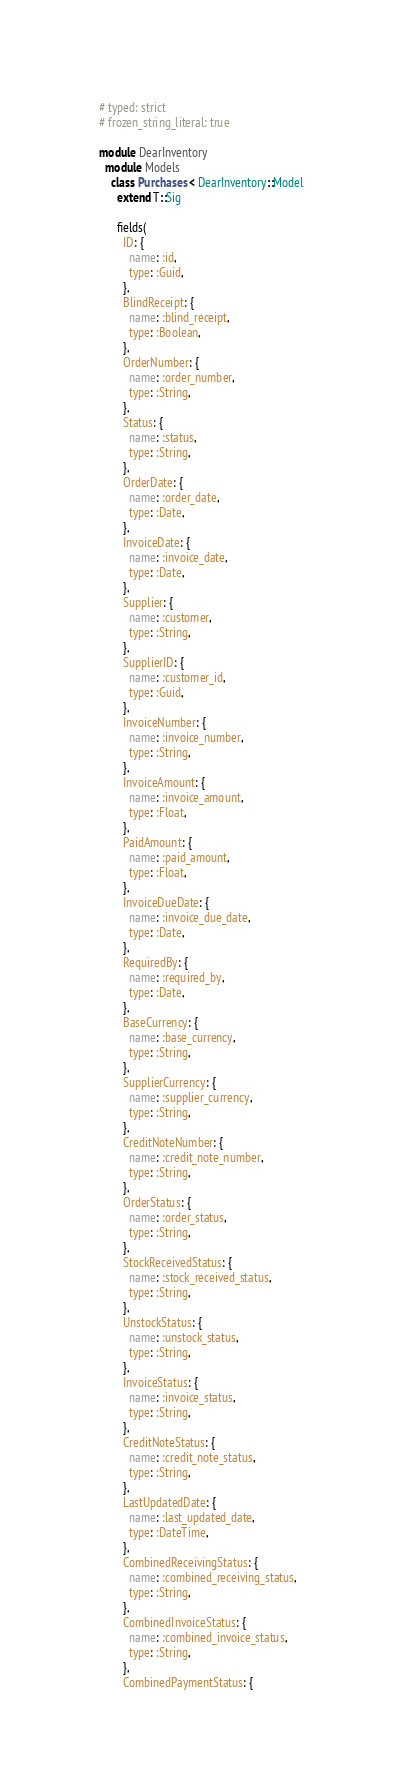<code> <loc_0><loc_0><loc_500><loc_500><_Ruby_># typed: strict
# frozen_string_literal: true

module DearInventory
  module Models
    class Purchases < DearInventory::Model
      extend T::Sig

      fields(
        ID: {
          name: :id,
          type: :Guid,
        },
        BlindReceipt: {
          name: :blind_receipt,
          type: :Boolean,
        },
        OrderNumber: {
          name: :order_number,
          type: :String,
        },
        Status: {
          name: :status,
          type: :String,
        },
        OrderDate: {
          name: :order_date,
          type: :Date,
        },
        InvoiceDate: {
          name: :invoice_date,
          type: :Date,
        },
        Supplier: {
          name: :customer,
          type: :String,
        },
        SupplierID: {
          name: :customer_id,
          type: :Guid,
        },
        InvoiceNumber: {
          name: :invoice_number,
          type: :String,
        },
        InvoiceAmount: {
          name: :invoice_amount,
          type: :Float,
        },
        PaidAmount: {
          name: :paid_amount,
          type: :Float,
        },
        InvoiceDueDate: {
          name: :invoice_due_date,
          type: :Date,
        },
        RequiredBy: {
          name: :required_by,
          type: :Date,
        },
        BaseCurrency: {
          name: :base_currency,
          type: :String,
        },
        SupplierCurrency: {
          name: :supplier_currency,
          type: :String,
        },
        CreditNoteNumber: {
          name: :credit_note_number,
          type: :String,
        },
        OrderStatus: {
          name: :order_status,
          type: :String,
        },
        StockReceivedStatus: {
          name: :stock_received_status,
          type: :String,
        },
        UnstockStatus: {
          name: :unstock_status,
          type: :String,
        },
        InvoiceStatus: {
          name: :invoice_status,
          type: :String,
        },
        CreditNoteStatus: {
          name: :credit_note_status,
          type: :String,
        },
        LastUpdatedDate: {
          name: :last_updated_date,
          type: :DateTime,
        },
        CombinedReceivingStatus: {
          name: :combined_receiving_status,
          type: :String,
        },
        CombinedInvoiceStatus: {
          name: :combined_invoice_status,
          type: :String,
        },
        CombinedPaymentStatus: {</code> 